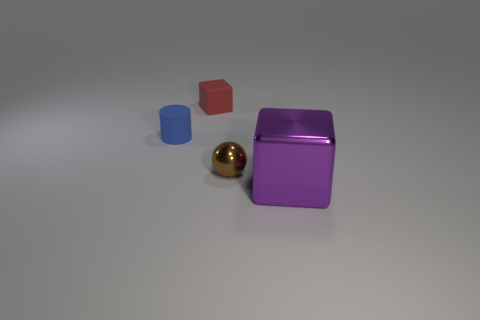What number of tiny cylinders are behind the block that is in front of the tiny object that is on the left side of the small red block?
Your response must be concise. 1. What number of red things are small matte blocks or large shiny things?
Give a very brief answer. 1. The purple shiny object that is to the right of the tiny sphere has what shape?
Your response must be concise. Cube. What is the color of the block that is the same size as the blue cylinder?
Ensure brevity in your answer.  Red. There is a large thing; does it have the same shape as the matte thing to the right of the blue object?
Keep it short and to the point. Yes. There is a small thing that is behind the tiny thing on the left side of the block behind the brown sphere; what is it made of?
Your answer should be very brief. Rubber. How many large things are either yellow objects or red rubber cubes?
Ensure brevity in your answer.  0. How many other things are there of the same size as the red rubber cube?
Your answer should be very brief. 2. There is a small matte thing to the right of the small cylinder; does it have the same shape as the large object?
Ensure brevity in your answer.  Yes. There is a large thing that is the same shape as the small red rubber thing; what is its color?
Keep it short and to the point. Purple. 